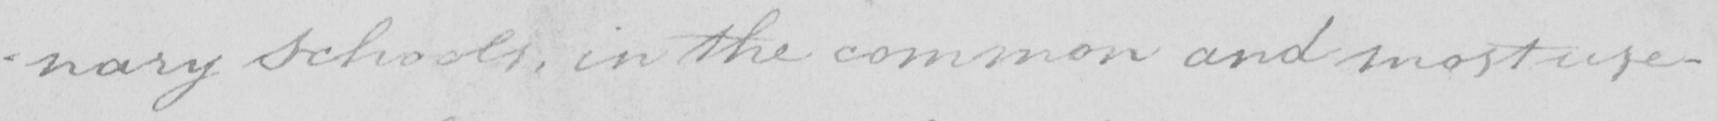Please transcribe the handwritten text in this image. -nary Schools , in the common and most use- 